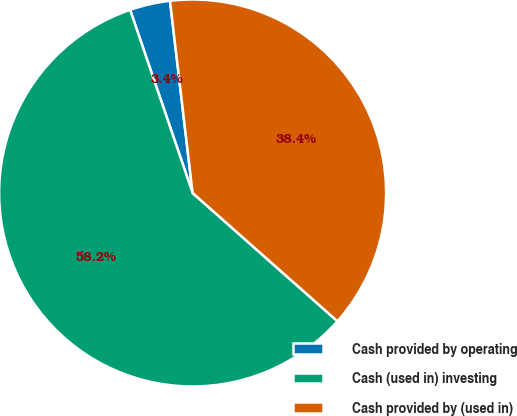Convert chart to OTSL. <chart><loc_0><loc_0><loc_500><loc_500><pie_chart><fcel>Cash provided by operating<fcel>Cash (used in) investing<fcel>Cash provided by (used in)<nl><fcel>3.37%<fcel>58.23%<fcel>38.4%<nl></chart> 